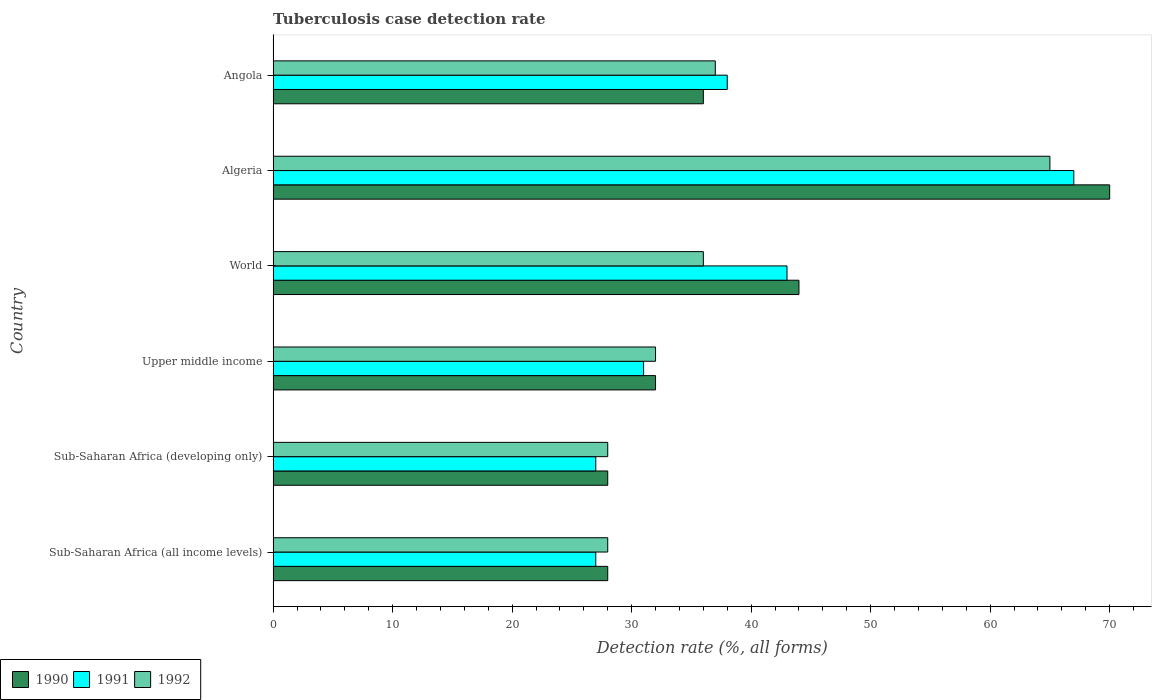Are the number of bars per tick equal to the number of legend labels?
Ensure brevity in your answer.  Yes. Are the number of bars on each tick of the Y-axis equal?
Your response must be concise. Yes. How many bars are there on the 6th tick from the top?
Provide a short and direct response. 3. What is the label of the 6th group of bars from the top?
Keep it short and to the point. Sub-Saharan Africa (all income levels). In how many cases, is the number of bars for a given country not equal to the number of legend labels?
Give a very brief answer. 0. What is the tuberculosis case detection rate in in 1990 in Upper middle income?
Keep it short and to the point. 32. In which country was the tuberculosis case detection rate in in 1992 maximum?
Give a very brief answer. Algeria. In which country was the tuberculosis case detection rate in in 1991 minimum?
Give a very brief answer. Sub-Saharan Africa (all income levels). What is the total tuberculosis case detection rate in in 1990 in the graph?
Provide a short and direct response. 238. What is the difference between the tuberculosis case detection rate in in 1992 in Angola and that in Upper middle income?
Your answer should be very brief. 5. What is the difference between the tuberculosis case detection rate in in 1992 in Algeria and the tuberculosis case detection rate in in 1991 in Sub-Saharan Africa (developing only)?
Your answer should be compact. 38. What is the average tuberculosis case detection rate in in 1991 per country?
Your answer should be compact. 38.83. What is the difference between the tuberculosis case detection rate in in 1991 and tuberculosis case detection rate in in 1990 in Algeria?
Your response must be concise. -3. In how many countries, is the tuberculosis case detection rate in in 1992 greater than 34 %?
Offer a very short reply. 3. What is the ratio of the tuberculosis case detection rate in in 1990 in Angola to that in Sub-Saharan Africa (developing only)?
Offer a terse response. 1.29. What is the difference between the highest and the second highest tuberculosis case detection rate in in 1990?
Your answer should be compact. 26. In how many countries, is the tuberculosis case detection rate in in 1990 greater than the average tuberculosis case detection rate in in 1990 taken over all countries?
Give a very brief answer. 2. Is the sum of the tuberculosis case detection rate in in 1992 in Sub-Saharan Africa (all income levels) and World greater than the maximum tuberculosis case detection rate in in 1990 across all countries?
Make the answer very short. No. What does the 1st bar from the top in Algeria represents?
Your answer should be very brief. 1992. What does the 1st bar from the bottom in World represents?
Ensure brevity in your answer.  1990. Are all the bars in the graph horizontal?
Provide a short and direct response. Yes. How many countries are there in the graph?
Your response must be concise. 6. Are the values on the major ticks of X-axis written in scientific E-notation?
Your answer should be compact. No. Does the graph contain grids?
Make the answer very short. No. How many legend labels are there?
Provide a succinct answer. 3. What is the title of the graph?
Keep it short and to the point. Tuberculosis case detection rate. Does "2012" appear as one of the legend labels in the graph?
Provide a succinct answer. No. What is the label or title of the X-axis?
Your answer should be compact. Detection rate (%, all forms). What is the label or title of the Y-axis?
Offer a very short reply. Country. What is the Detection rate (%, all forms) of 1990 in Sub-Saharan Africa (all income levels)?
Ensure brevity in your answer.  28. What is the Detection rate (%, all forms) in 1991 in Sub-Saharan Africa (all income levels)?
Your answer should be very brief. 27. What is the Detection rate (%, all forms) in 1992 in Sub-Saharan Africa (all income levels)?
Make the answer very short. 28. What is the Detection rate (%, all forms) of 1990 in Sub-Saharan Africa (developing only)?
Offer a terse response. 28. What is the Detection rate (%, all forms) in 1991 in Sub-Saharan Africa (developing only)?
Offer a terse response. 27. What is the Detection rate (%, all forms) of 1992 in Sub-Saharan Africa (developing only)?
Your answer should be very brief. 28. What is the Detection rate (%, all forms) in 1990 in Upper middle income?
Your answer should be compact. 32. What is the Detection rate (%, all forms) of 1992 in Upper middle income?
Your answer should be compact. 32. What is the Detection rate (%, all forms) in 1990 in World?
Your answer should be compact. 44. What is the Detection rate (%, all forms) of 1991 in World?
Provide a short and direct response. 43. What is the Detection rate (%, all forms) of 1992 in World?
Make the answer very short. 36. What is the Detection rate (%, all forms) of 1990 in Algeria?
Ensure brevity in your answer.  70. What is the Detection rate (%, all forms) of 1991 in Algeria?
Make the answer very short. 67. What is the Detection rate (%, all forms) in 1992 in Algeria?
Keep it short and to the point. 65. What is the Detection rate (%, all forms) of 1991 in Angola?
Offer a terse response. 38. What is the Detection rate (%, all forms) in 1992 in Angola?
Give a very brief answer. 37. Across all countries, what is the maximum Detection rate (%, all forms) of 1992?
Your answer should be very brief. 65. Across all countries, what is the minimum Detection rate (%, all forms) in 1990?
Offer a very short reply. 28. Across all countries, what is the minimum Detection rate (%, all forms) of 1992?
Make the answer very short. 28. What is the total Detection rate (%, all forms) in 1990 in the graph?
Provide a short and direct response. 238. What is the total Detection rate (%, all forms) in 1991 in the graph?
Keep it short and to the point. 233. What is the total Detection rate (%, all forms) of 1992 in the graph?
Give a very brief answer. 226. What is the difference between the Detection rate (%, all forms) in 1990 in Sub-Saharan Africa (all income levels) and that in Sub-Saharan Africa (developing only)?
Offer a terse response. 0. What is the difference between the Detection rate (%, all forms) of 1992 in Sub-Saharan Africa (all income levels) and that in Sub-Saharan Africa (developing only)?
Offer a very short reply. 0. What is the difference between the Detection rate (%, all forms) in 1991 in Sub-Saharan Africa (all income levels) and that in Upper middle income?
Keep it short and to the point. -4. What is the difference between the Detection rate (%, all forms) in 1992 in Sub-Saharan Africa (all income levels) and that in Upper middle income?
Give a very brief answer. -4. What is the difference between the Detection rate (%, all forms) in 1991 in Sub-Saharan Africa (all income levels) and that in World?
Provide a short and direct response. -16. What is the difference between the Detection rate (%, all forms) of 1992 in Sub-Saharan Africa (all income levels) and that in World?
Keep it short and to the point. -8. What is the difference between the Detection rate (%, all forms) of 1990 in Sub-Saharan Africa (all income levels) and that in Algeria?
Offer a very short reply. -42. What is the difference between the Detection rate (%, all forms) in 1992 in Sub-Saharan Africa (all income levels) and that in Algeria?
Provide a succinct answer. -37. What is the difference between the Detection rate (%, all forms) of 1992 in Sub-Saharan Africa (all income levels) and that in Angola?
Provide a short and direct response. -9. What is the difference between the Detection rate (%, all forms) in 1991 in Sub-Saharan Africa (developing only) and that in Upper middle income?
Keep it short and to the point. -4. What is the difference between the Detection rate (%, all forms) in 1992 in Sub-Saharan Africa (developing only) and that in Upper middle income?
Your answer should be compact. -4. What is the difference between the Detection rate (%, all forms) in 1990 in Sub-Saharan Africa (developing only) and that in Algeria?
Offer a terse response. -42. What is the difference between the Detection rate (%, all forms) of 1991 in Sub-Saharan Africa (developing only) and that in Algeria?
Give a very brief answer. -40. What is the difference between the Detection rate (%, all forms) of 1992 in Sub-Saharan Africa (developing only) and that in Algeria?
Make the answer very short. -37. What is the difference between the Detection rate (%, all forms) of 1991 in Sub-Saharan Africa (developing only) and that in Angola?
Provide a succinct answer. -11. What is the difference between the Detection rate (%, all forms) of 1992 in Sub-Saharan Africa (developing only) and that in Angola?
Keep it short and to the point. -9. What is the difference between the Detection rate (%, all forms) in 1992 in Upper middle income and that in World?
Your response must be concise. -4. What is the difference between the Detection rate (%, all forms) of 1990 in Upper middle income and that in Algeria?
Give a very brief answer. -38. What is the difference between the Detection rate (%, all forms) in 1991 in Upper middle income and that in Algeria?
Give a very brief answer. -36. What is the difference between the Detection rate (%, all forms) of 1992 in Upper middle income and that in Algeria?
Your answer should be very brief. -33. What is the difference between the Detection rate (%, all forms) in 1991 in Upper middle income and that in Angola?
Your answer should be compact. -7. What is the difference between the Detection rate (%, all forms) of 1991 in World and that in Algeria?
Ensure brevity in your answer.  -24. What is the difference between the Detection rate (%, all forms) of 1990 in World and that in Angola?
Provide a short and direct response. 8. What is the difference between the Detection rate (%, all forms) of 1991 in World and that in Angola?
Provide a succinct answer. 5. What is the difference between the Detection rate (%, all forms) in 1992 in World and that in Angola?
Ensure brevity in your answer.  -1. What is the difference between the Detection rate (%, all forms) in 1990 in Algeria and that in Angola?
Provide a succinct answer. 34. What is the difference between the Detection rate (%, all forms) of 1990 in Sub-Saharan Africa (all income levels) and the Detection rate (%, all forms) of 1992 in Sub-Saharan Africa (developing only)?
Your response must be concise. 0. What is the difference between the Detection rate (%, all forms) of 1991 in Sub-Saharan Africa (all income levels) and the Detection rate (%, all forms) of 1992 in Sub-Saharan Africa (developing only)?
Provide a short and direct response. -1. What is the difference between the Detection rate (%, all forms) of 1990 in Sub-Saharan Africa (all income levels) and the Detection rate (%, all forms) of 1991 in Upper middle income?
Make the answer very short. -3. What is the difference between the Detection rate (%, all forms) in 1990 in Sub-Saharan Africa (all income levels) and the Detection rate (%, all forms) in 1992 in Upper middle income?
Your answer should be compact. -4. What is the difference between the Detection rate (%, all forms) in 1991 in Sub-Saharan Africa (all income levels) and the Detection rate (%, all forms) in 1992 in Upper middle income?
Your response must be concise. -5. What is the difference between the Detection rate (%, all forms) of 1990 in Sub-Saharan Africa (all income levels) and the Detection rate (%, all forms) of 1992 in World?
Keep it short and to the point. -8. What is the difference between the Detection rate (%, all forms) in 1990 in Sub-Saharan Africa (all income levels) and the Detection rate (%, all forms) in 1991 in Algeria?
Make the answer very short. -39. What is the difference between the Detection rate (%, all forms) of 1990 in Sub-Saharan Africa (all income levels) and the Detection rate (%, all forms) of 1992 in Algeria?
Make the answer very short. -37. What is the difference between the Detection rate (%, all forms) of 1991 in Sub-Saharan Africa (all income levels) and the Detection rate (%, all forms) of 1992 in Algeria?
Offer a terse response. -38. What is the difference between the Detection rate (%, all forms) in 1990 in Sub-Saharan Africa (all income levels) and the Detection rate (%, all forms) in 1992 in Angola?
Your answer should be compact. -9. What is the difference between the Detection rate (%, all forms) in 1990 in Sub-Saharan Africa (developing only) and the Detection rate (%, all forms) in 1991 in World?
Offer a terse response. -15. What is the difference between the Detection rate (%, all forms) in 1990 in Sub-Saharan Africa (developing only) and the Detection rate (%, all forms) in 1991 in Algeria?
Keep it short and to the point. -39. What is the difference between the Detection rate (%, all forms) of 1990 in Sub-Saharan Africa (developing only) and the Detection rate (%, all forms) of 1992 in Algeria?
Provide a succinct answer. -37. What is the difference between the Detection rate (%, all forms) of 1991 in Sub-Saharan Africa (developing only) and the Detection rate (%, all forms) of 1992 in Algeria?
Keep it short and to the point. -38. What is the difference between the Detection rate (%, all forms) in 1990 in Sub-Saharan Africa (developing only) and the Detection rate (%, all forms) in 1991 in Angola?
Give a very brief answer. -10. What is the difference between the Detection rate (%, all forms) in 1990 in Upper middle income and the Detection rate (%, all forms) in 1992 in World?
Offer a terse response. -4. What is the difference between the Detection rate (%, all forms) in 1990 in Upper middle income and the Detection rate (%, all forms) in 1991 in Algeria?
Keep it short and to the point. -35. What is the difference between the Detection rate (%, all forms) in 1990 in Upper middle income and the Detection rate (%, all forms) in 1992 in Algeria?
Offer a very short reply. -33. What is the difference between the Detection rate (%, all forms) in 1991 in Upper middle income and the Detection rate (%, all forms) in 1992 in Algeria?
Your answer should be very brief. -34. What is the difference between the Detection rate (%, all forms) of 1991 in Upper middle income and the Detection rate (%, all forms) of 1992 in Angola?
Ensure brevity in your answer.  -6. What is the difference between the Detection rate (%, all forms) of 1990 in World and the Detection rate (%, all forms) of 1992 in Algeria?
Keep it short and to the point. -21. What is the difference between the Detection rate (%, all forms) in 1990 in World and the Detection rate (%, all forms) in 1991 in Angola?
Your answer should be compact. 6. What is the average Detection rate (%, all forms) of 1990 per country?
Ensure brevity in your answer.  39.67. What is the average Detection rate (%, all forms) in 1991 per country?
Your answer should be compact. 38.83. What is the average Detection rate (%, all forms) of 1992 per country?
Your response must be concise. 37.67. What is the difference between the Detection rate (%, all forms) in 1990 and Detection rate (%, all forms) in 1991 in Sub-Saharan Africa (all income levels)?
Your answer should be compact. 1. What is the difference between the Detection rate (%, all forms) of 1990 and Detection rate (%, all forms) of 1992 in Sub-Saharan Africa (all income levels)?
Make the answer very short. 0. What is the difference between the Detection rate (%, all forms) in 1991 and Detection rate (%, all forms) in 1992 in Sub-Saharan Africa (all income levels)?
Make the answer very short. -1. What is the difference between the Detection rate (%, all forms) in 1990 and Detection rate (%, all forms) in 1991 in Sub-Saharan Africa (developing only)?
Your answer should be compact. 1. What is the difference between the Detection rate (%, all forms) in 1991 and Detection rate (%, all forms) in 1992 in Sub-Saharan Africa (developing only)?
Your answer should be compact. -1. What is the difference between the Detection rate (%, all forms) in 1990 and Detection rate (%, all forms) in 1991 in Upper middle income?
Your answer should be very brief. 1. What is the difference between the Detection rate (%, all forms) in 1990 and Detection rate (%, all forms) in 1992 in Upper middle income?
Your answer should be compact. 0. What is the difference between the Detection rate (%, all forms) of 1991 and Detection rate (%, all forms) of 1992 in Upper middle income?
Keep it short and to the point. -1. What is the difference between the Detection rate (%, all forms) in 1991 and Detection rate (%, all forms) in 1992 in World?
Provide a short and direct response. 7. What is the difference between the Detection rate (%, all forms) of 1990 and Detection rate (%, all forms) of 1991 in Algeria?
Offer a terse response. 3. What is the ratio of the Detection rate (%, all forms) of 1990 in Sub-Saharan Africa (all income levels) to that in Sub-Saharan Africa (developing only)?
Make the answer very short. 1. What is the ratio of the Detection rate (%, all forms) in 1991 in Sub-Saharan Africa (all income levels) to that in Sub-Saharan Africa (developing only)?
Offer a terse response. 1. What is the ratio of the Detection rate (%, all forms) in 1991 in Sub-Saharan Africa (all income levels) to that in Upper middle income?
Your response must be concise. 0.87. What is the ratio of the Detection rate (%, all forms) in 1992 in Sub-Saharan Africa (all income levels) to that in Upper middle income?
Your answer should be very brief. 0.88. What is the ratio of the Detection rate (%, all forms) of 1990 in Sub-Saharan Africa (all income levels) to that in World?
Provide a short and direct response. 0.64. What is the ratio of the Detection rate (%, all forms) in 1991 in Sub-Saharan Africa (all income levels) to that in World?
Offer a very short reply. 0.63. What is the ratio of the Detection rate (%, all forms) in 1992 in Sub-Saharan Africa (all income levels) to that in World?
Offer a terse response. 0.78. What is the ratio of the Detection rate (%, all forms) of 1991 in Sub-Saharan Africa (all income levels) to that in Algeria?
Offer a very short reply. 0.4. What is the ratio of the Detection rate (%, all forms) in 1992 in Sub-Saharan Africa (all income levels) to that in Algeria?
Make the answer very short. 0.43. What is the ratio of the Detection rate (%, all forms) in 1991 in Sub-Saharan Africa (all income levels) to that in Angola?
Offer a terse response. 0.71. What is the ratio of the Detection rate (%, all forms) of 1992 in Sub-Saharan Africa (all income levels) to that in Angola?
Your answer should be compact. 0.76. What is the ratio of the Detection rate (%, all forms) in 1990 in Sub-Saharan Africa (developing only) to that in Upper middle income?
Provide a short and direct response. 0.88. What is the ratio of the Detection rate (%, all forms) of 1991 in Sub-Saharan Africa (developing only) to that in Upper middle income?
Offer a very short reply. 0.87. What is the ratio of the Detection rate (%, all forms) in 1990 in Sub-Saharan Africa (developing only) to that in World?
Offer a very short reply. 0.64. What is the ratio of the Detection rate (%, all forms) in 1991 in Sub-Saharan Africa (developing only) to that in World?
Provide a short and direct response. 0.63. What is the ratio of the Detection rate (%, all forms) in 1991 in Sub-Saharan Africa (developing only) to that in Algeria?
Your response must be concise. 0.4. What is the ratio of the Detection rate (%, all forms) in 1992 in Sub-Saharan Africa (developing only) to that in Algeria?
Your answer should be very brief. 0.43. What is the ratio of the Detection rate (%, all forms) of 1990 in Sub-Saharan Africa (developing only) to that in Angola?
Provide a short and direct response. 0.78. What is the ratio of the Detection rate (%, all forms) of 1991 in Sub-Saharan Africa (developing only) to that in Angola?
Give a very brief answer. 0.71. What is the ratio of the Detection rate (%, all forms) in 1992 in Sub-Saharan Africa (developing only) to that in Angola?
Your answer should be very brief. 0.76. What is the ratio of the Detection rate (%, all forms) of 1990 in Upper middle income to that in World?
Offer a very short reply. 0.73. What is the ratio of the Detection rate (%, all forms) in 1991 in Upper middle income to that in World?
Keep it short and to the point. 0.72. What is the ratio of the Detection rate (%, all forms) of 1992 in Upper middle income to that in World?
Your answer should be very brief. 0.89. What is the ratio of the Detection rate (%, all forms) in 1990 in Upper middle income to that in Algeria?
Provide a succinct answer. 0.46. What is the ratio of the Detection rate (%, all forms) of 1991 in Upper middle income to that in Algeria?
Provide a short and direct response. 0.46. What is the ratio of the Detection rate (%, all forms) of 1992 in Upper middle income to that in Algeria?
Offer a terse response. 0.49. What is the ratio of the Detection rate (%, all forms) of 1991 in Upper middle income to that in Angola?
Offer a terse response. 0.82. What is the ratio of the Detection rate (%, all forms) in 1992 in Upper middle income to that in Angola?
Give a very brief answer. 0.86. What is the ratio of the Detection rate (%, all forms) in 1990 in World to that in Algeria?
Your answer should be compact. 0.63. What is the ratio of the Detection rate (%, all forms) of 1991 in World to that in Algeria?
Keep it short and to the point. 0.64. What is the ratio of the Detection rate (%, all forms) in 1992 in World to that in Algeria?
Offer a very short reply. 0.55. What is the ratio of the Detection rate (%, all forms) in 1990 in World to that in Angola?
Your response must be concise. 1.22. What is the ratio of the Detection rate (%, all forms) in 1991 in World to that in Angola?
Ensure brevity in your answer.  1.13. What is the ratio of the Detection rate (%, all forms) in 1992 in World to that in Angola?
Give a very brief answer. 0.97. What is the ratio of the Detection rate (%, all forms) in 1990 in Algeria to that in Angola?
Make the answer very short. 1.94. What is the ratio of the Detection rate (%, all forms) in 1991 in Algeria to that in Angola?
Your answer should be compact. 1.76. What is the ratio of the Detection rate (%, all forms) in 1992 in Algeria to that in Angola?
Keep it short and to the point. 1.76. What is the difference between the highest and the lowest Detection rate (%, all forms) of 1990?
Your answer should be very brief. 42. What is the difference between the highest and the lowest Detection rate (%, all forms) in 1992?
Offer a terse response. 37. 